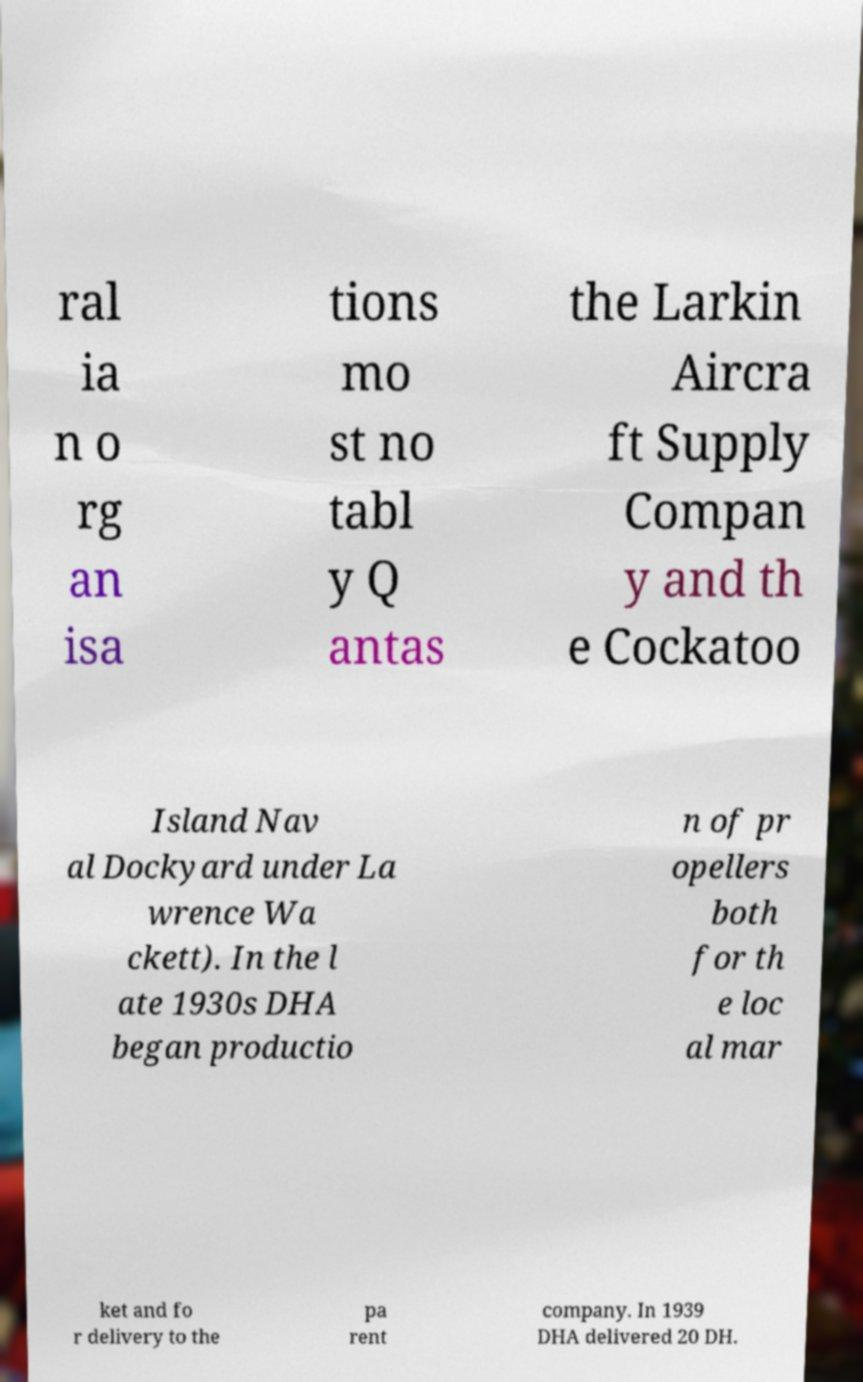Can you read and provide the text displayed in the image?This photo seems to have some interesting text. Can you extract and type it out for me? ral ia n o rg an isa tions mo st no tabl y Q antas the Larkin Aircra ft Supply Compan y and th e Cockatoo Island Nav al Dockyard under La wrence Wa ckett). In the l ate 1930s DHA began productio n of pr opellers both for th e loc al mar ket and fo r delivery to the pa rent company. In 1939 DHA delivered 20 DH. 